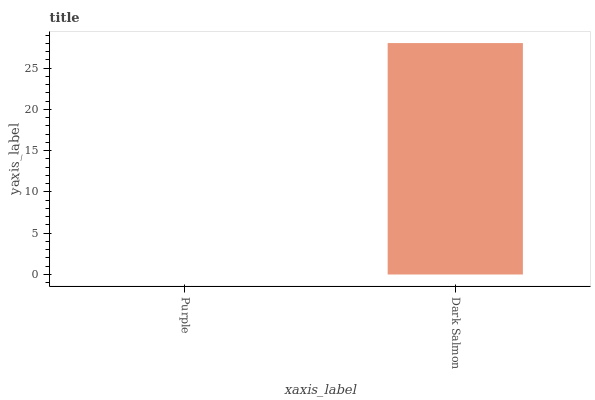Is Purple the minimum?
Answer yes or no. Yes. Is Dark Salmon the maximum?
Answer yes or no. Yes. Is Dark Salmon the minimum?
Answer yes or no. No. Is Dark Salmon greater than Purple?
Answer yes or no. Yes. Is Purple less than Dark Salmon?
Answer yes or no. Yes. Is Purple greater than Dark Salmon?
Answer yes or no. No. Is Dark Salmon less than Purple?
Answer yes or no. No. Is Dark Salmon the high median?
Answer yes or no. Yes. Is Purple the low median?
Answer yes or no. Yes. Is Purple the high median?
Answer yes or no. No. Is Dark Salmon the low median?
Answer yes or no. No. 